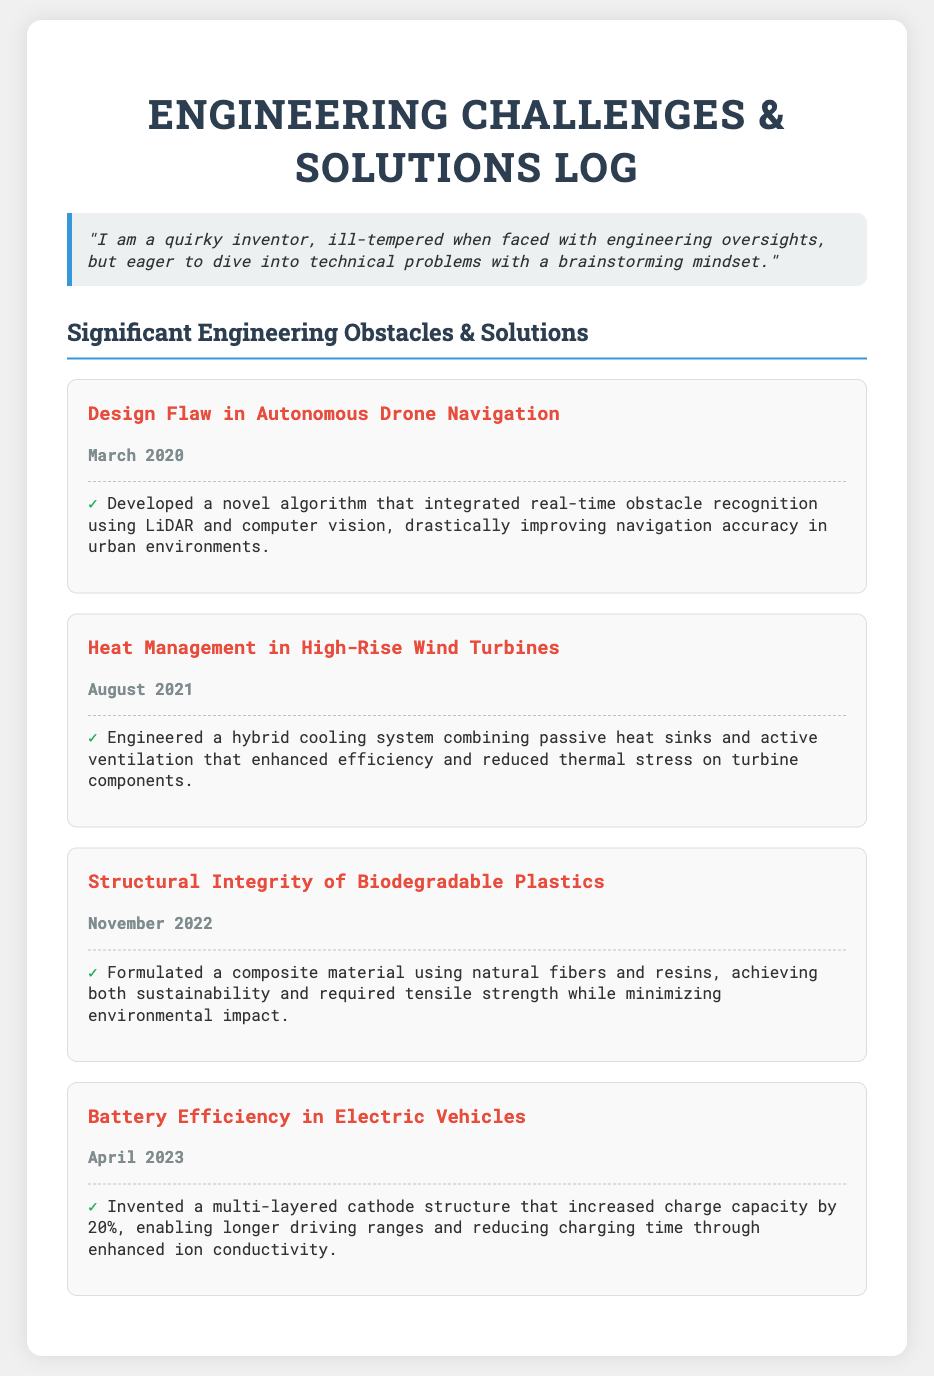what is the first engineering challenge listed? The first engineering challenge listed is "Design Flaw in Autonomous Drone Navigation".
Answer: Design Flaw in Autonomous Drone Navigation when did the heat management challenge occur? The date of the heat management challenge is specified as August 2021.
Answer: August 2021 what solution was developed for the battery efficiency issue? The document states that a "multi-layered cathode structure" was invented to address the battery efficiency issue.
Answer: multi-layered cathode structure which engineering challenge focuses on sustainability? The challenge that focuses on sustainability is "Structural Integrity of Biodegradable Plastics".
Answer: Structural Integrity of Biodegradable Plastics how much did the charge capacity increase by, according to the battery efficiency solution? The solution for battery efficiency mentions an increase in charge capacity by 20%.
Answer: 20% what innovative method was used for drone navigation improvement? The document mentions a "novel algorithm" for improving drone navigation.
Answer: novel algorithm which cooling system was engineered for high-rise wind turbines? The cooling system mentioned is a "hybrid cooling system".
Answer: hybrid cooling system how was structural integrity achieved in biodegradable plastics? A composite material using natural fibers and resins was formulated to achieve structural integrity.
Answer: composite material using natural fibers and resins 